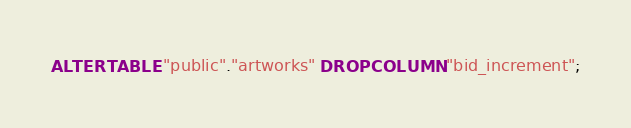Convert code to text. <code><loc_0><loc_0><loc_500><loc_500><_SQL_>ALTER TABLE "public"."artworks" DROP COLUMN "bid_increment";
</code> 